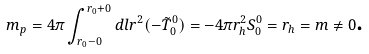Convert formula to latex. <formula><loc_0><loc_0><loc_500><loc_500>m _ { p } = 4 \pi \int _ { r _ { 0 } - 0 } ^ { r _ { 0 } + 0 } d l r ^ { 2 } ( - \tilde { T } _ { 0 } ^ { 0 } ) = - 4 \pi r _ { h } ^ { 2 } S _ { 0 } ^ { 0 } = r _ { h } = m \neq 0 \text {.}</formula> 